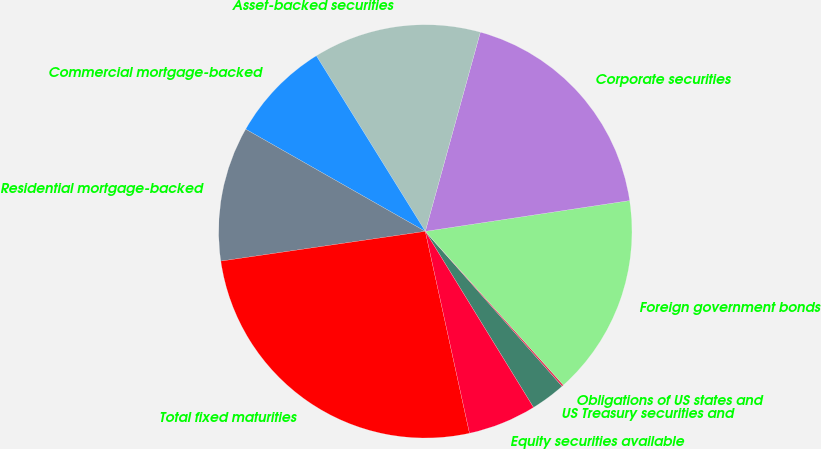Convert chart to OTSL. <chart><loc_0><loc_0><loc_500><loc_500><pie_chart><fcel>US Treasury securities and<fcel>Obligations of US states and<fcel>Foreign government bonds<fcel>Corporate securities<fcel>Asset-backed securities<fcel>Commercial mortgage-backed<fcel>Residential mortgage-backed<fcel>Total fixed maturities<fcel>Equity securities available<nl><fcel>2.74%<fcel>0.14%<fcel>15.73%<fcel>18.33%<fcel>13.13%<fcel>7.93%<fcel>10.53%<fcel>26.13%<fcel>5.34%<nl></chart> 